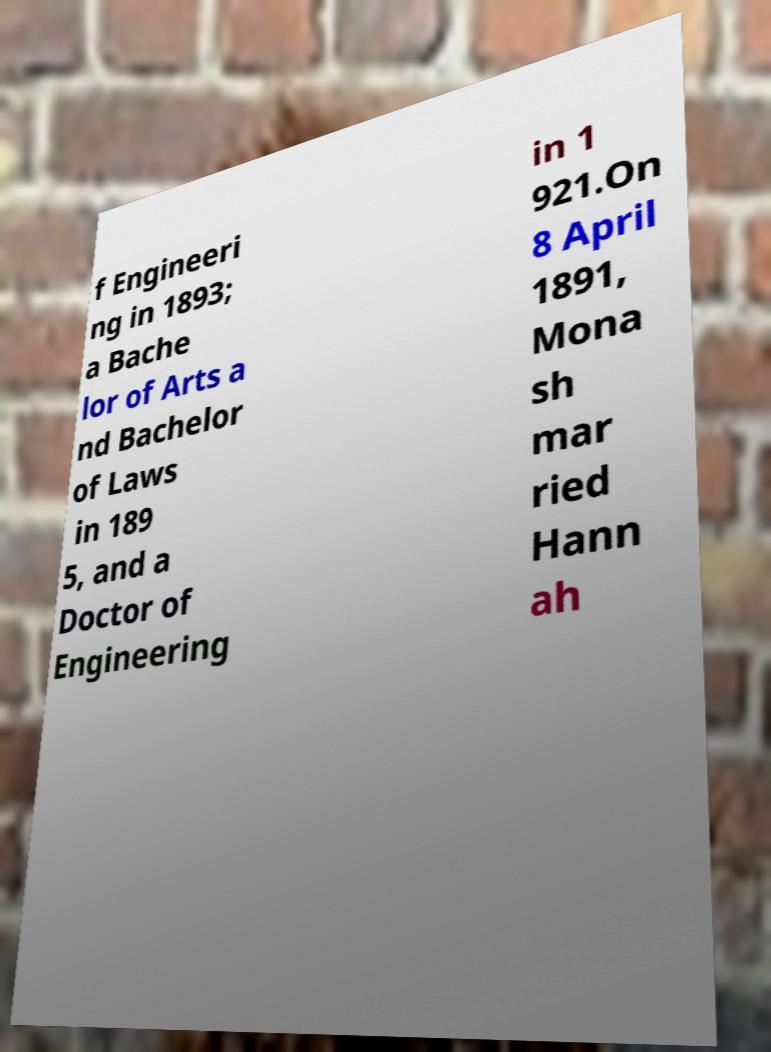Can you read and provide the text displayed in the image?This photo seems to have some interesting text. Can you extract and type it out for me? f Engineeri ng in 1893; a Bache lor of Arts a nd Bachelor of Laws in 189 5, and a Doctor of Engineering in 1 921.On 8 April 1891, Mona sh mar ried Hann ah 